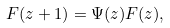<formula> <loc_0><loc_0><loc_500><loc_500>F ( z + 1 ) = \Psi ( z ) F ( z ) ,</formula> 